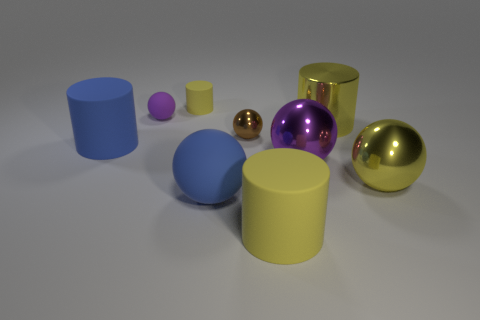There is a rubber cylinder on the right side of the tiny brown object; how many large purple balls are to the left of it?
Keep it short and to the point. 0. Are there more purple things that are in front of the large matte sphere than blue matte objects?
Your answer should be compact. No. There is a sphere that is in front of the yellow shiny cylinder and on the left side of the brown metallic sphere; what is its size?
Your answer should be very brief. Large. What is the shape of the yellow object that is both to the right of the tiny yellow rubber cylinder and behind the big blue cylinder?
Offer a terse response. Cylinder. There is a cylinder right of the yellow matte cylinder that is in front of the tiny cylinder; are there any small things that are to the right of it?
Offer a very short reply. No. How many things are either big yellow things that are on the left side of the big yellow metal cylinder or large metallic things in front of the brown shiny ball?
Offer a very short reply. 3. Does the ball that is left of the tiny yellow object have the same material as the tiny yellow object?
Provide a short and direct response. Yes. There is a thing that is both in front of the small shiny thing and to the left of the small cylinder; what is it made of?
Your answer should be very brief. Rubber. There is a large cylinder that is right of the big matte cylinder to the right of the tiny purple rubber thing; what is its color?
Ensure brevity in your answer.  Yellow. There is another purple object that is the same shape as the large purple metal object; what is it made of?
Your answer should be very brief. Rubber. 